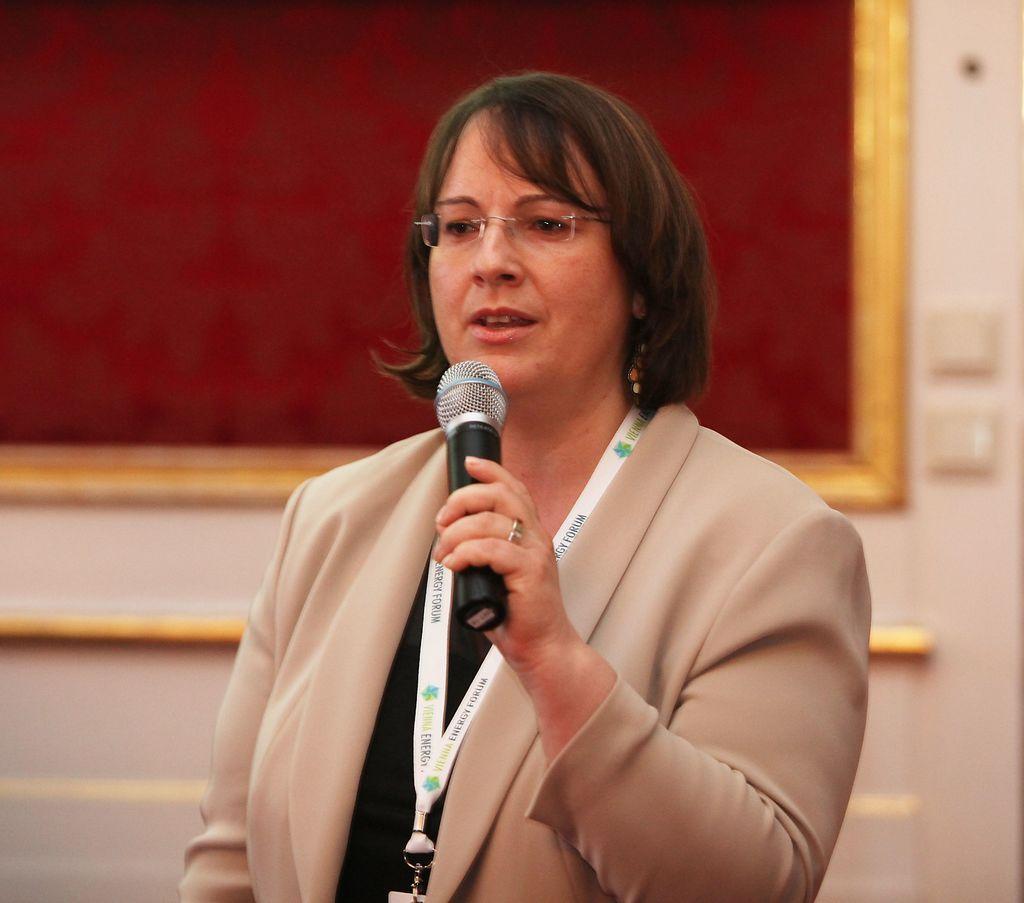In one or two sentences, can you explain what this image depicts? In this picture we can see woman holding mic in her hand and talking, she wore blazer, ID Card, spectacle and in background we can see wall, board. 